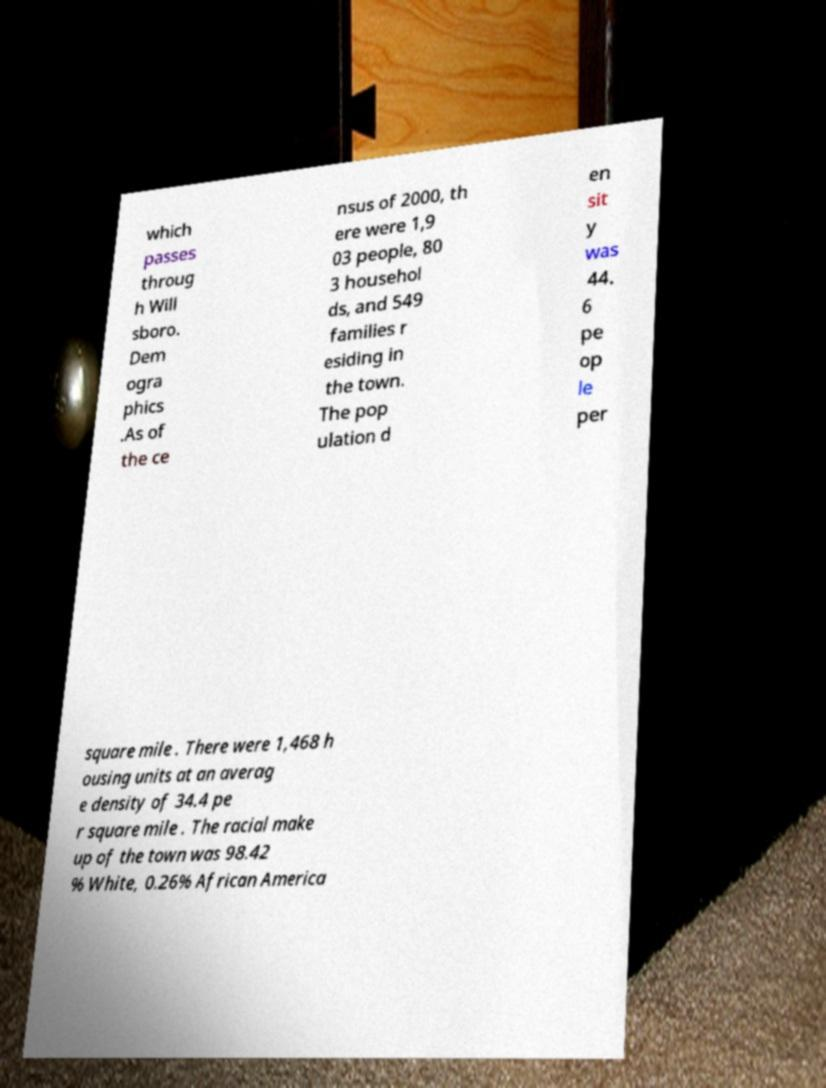Please read and relay the text visible in this image. What does it say? which passes throug h Will sboro. Dem ogra phics .As of the ce nsus of 2000, th ere were 1,9 03 people, 80 3 househol ds, and 549 families r esiding in the town. The pop ulation d en sit y was 44. 6 pe op le per square mile . There were 1,468 h ousing units at an averag e density of 34.4 pe r square mile . The racial make up of the town was 98.42 % White, 0.26% African America 